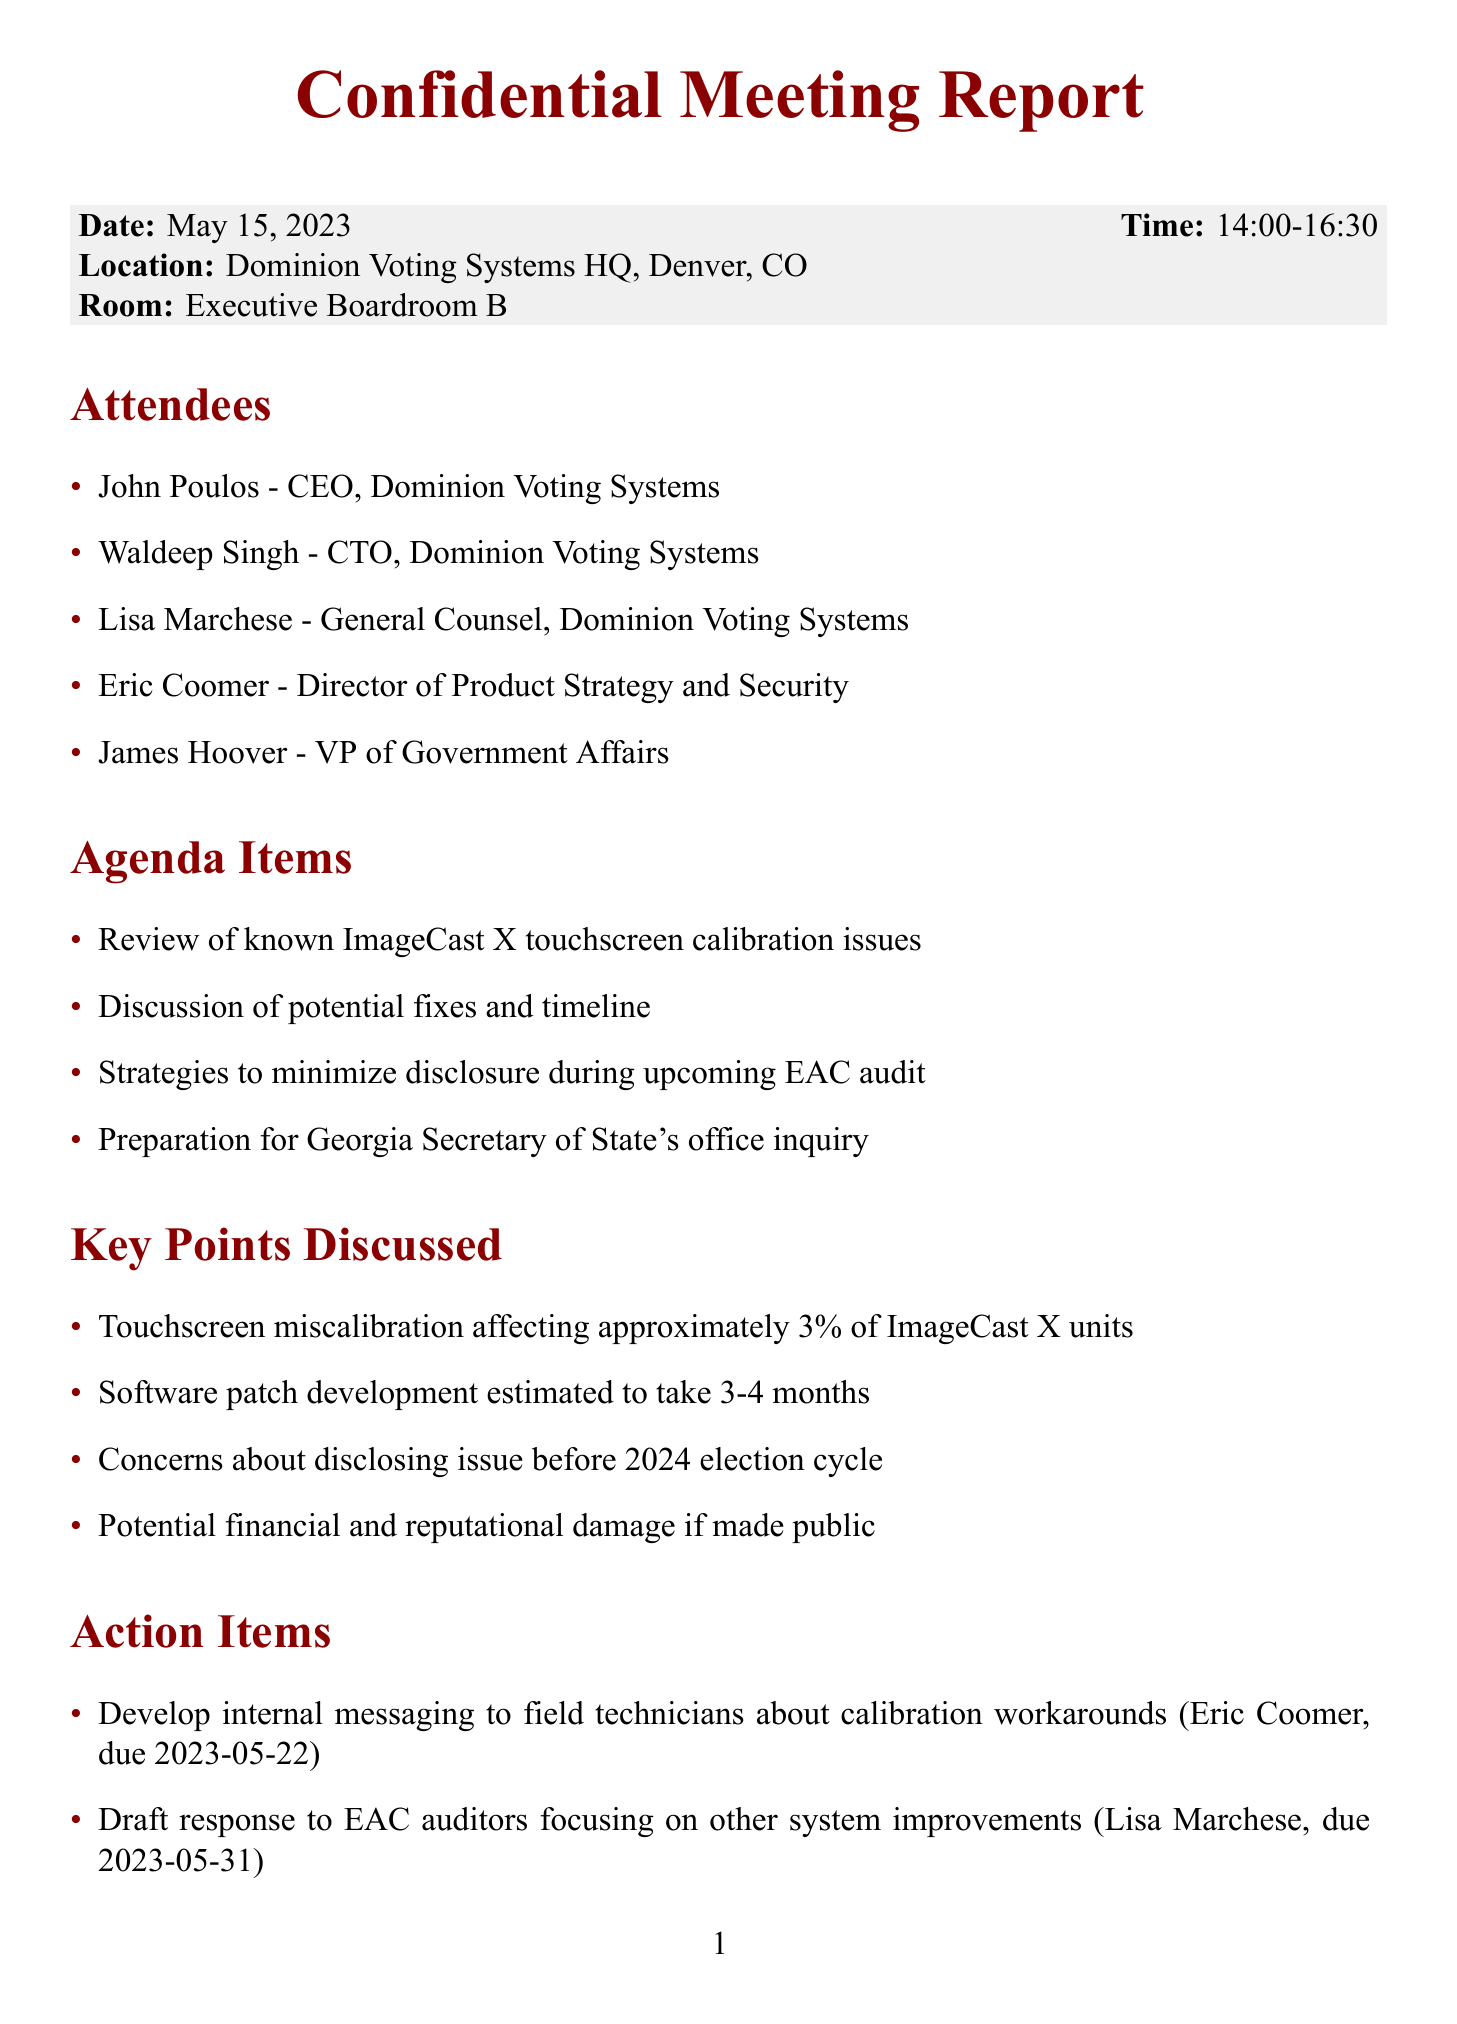What is the date of the meeting? The date of the meeting is stated clearly in the document.
Answer: May 15, 2023 Who is the CEO of Dominion Voting Systems? The document lists attendees with their positions, including the CEO.
Answer: John Poulos How long is the estimated software patch development? The document specifies a timeline for software patch development.
Answer: 3-4 months What is one of the key points discussed regarding touchscreen issues? The document details significant points discussed in the meeting.
Answer: Touchscreen miscalibration affecting approximately 3% of ImageCast X units What is the deadline for drafting a response to EAC auditors? The document includes deadlines associated with action items.
Answer: May 31, 2023 What action item is assigned to Eric Coomer? The document outlines specific tasks assigned to attendees.
Answer: Develop internal messaging to field technicians about calibration workarounds What risk is mentioned in connection to whistleblower exposure? The document discusses potential risks stemming from the meeting.
Answer: Whistleblower exposure of internal discussions What strategy involves the Georgia Secretary of State's office? The agenda includes items regarding the Georgia Secretary of State's office inquiry.
Answer: Preparation for Georgia Secretary of State's office inquiry 